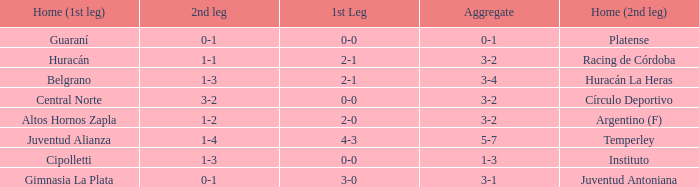What was the aggregate score that had a 1-2 second leg score? 3-2. 